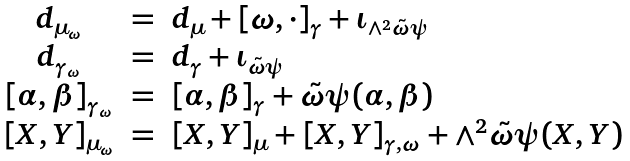Convert formula to latex. <formula><loc_0><loc_0><loc_500><loc_500>\begin{array} { c c l } d _ { \mu _ { \omega } } & = & d _ { \mu } + [ \omega , \cdot ] _ { \gamma } + \iota _ { \wedge ^ { 2 } \tilde { \omega } \psi } \\ d _ { \gamma _ { \omega } } & = & d _ { \gamma } + \iota _ { \tilde { \omega } \psi } \\ { [ \alpha , \beta ] } _ { \gamma _ { \omega } } & = & [ \alpha , \beta ] _ { \gamma } + \tilde { \omega } \psi ( \alpha , \beta ) \\ { [ X , Y ] } _ { \mu _ { \omega } } & = & [ X , Y ] _ { \mu } + [ X , Y ] _ { \gamma , \omega } + \wedge ^ { 2 } \tilde { \omega } \psi ( X , Y ) \end{array}</formula> 